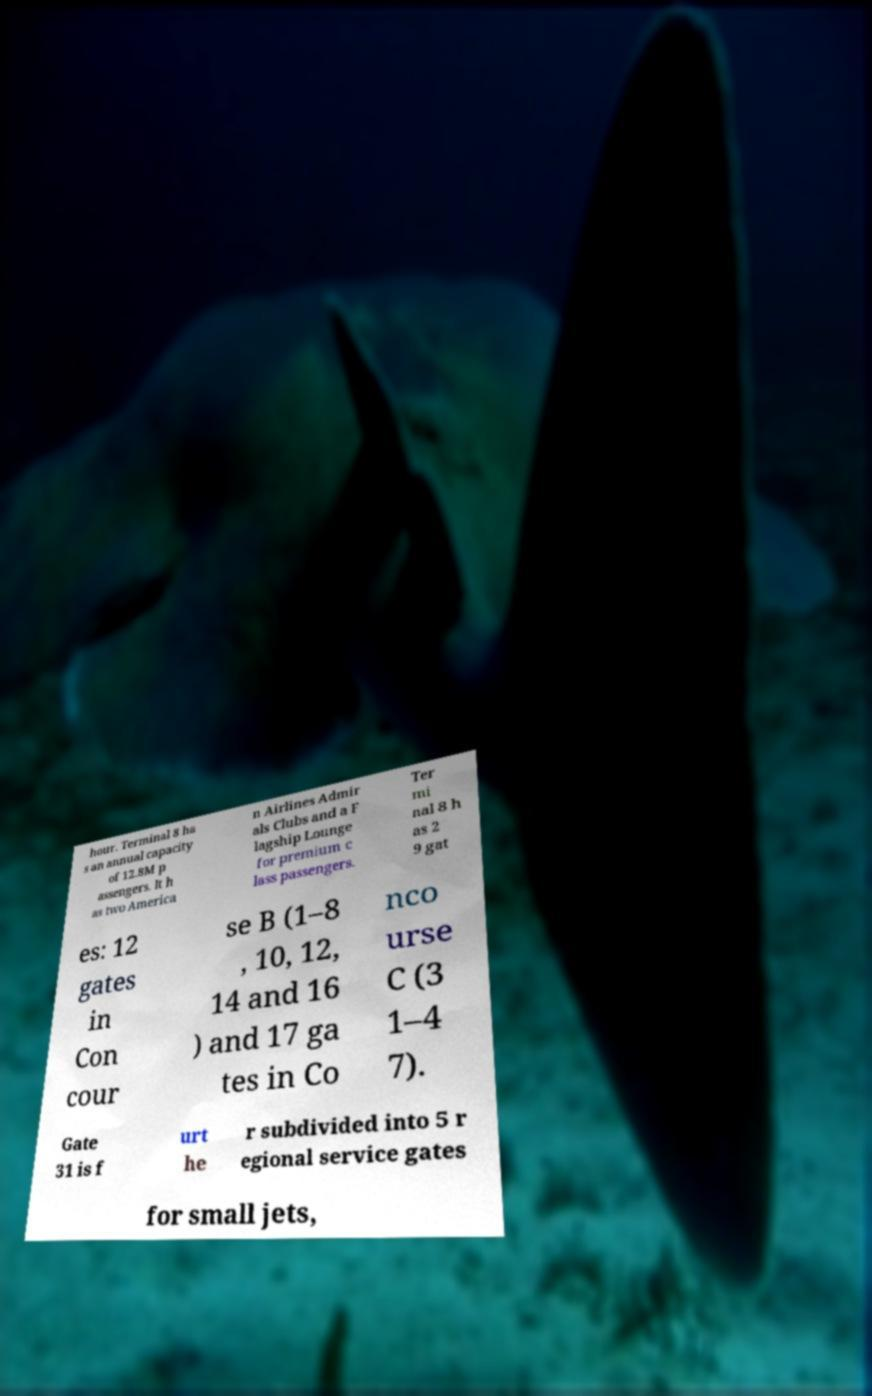Could you extract and type out the text from this image? hour. Terminal 8 ha s an annual capacity of 12.8M p assengers. It h as two America n Airlines Admir als Clubs and a F lagship Lounge for premium c lass passengers. Ter mi nal 8 h as 2 9 gat es: 12 gates in Con cour se B (1–8 , 10, 12, 14 and 16 ) and 17 ga tes in Co nco urse C (3 1–4 7). Gate 31 is f urt he r subdivided into 5 r egional service gates for small jets, 